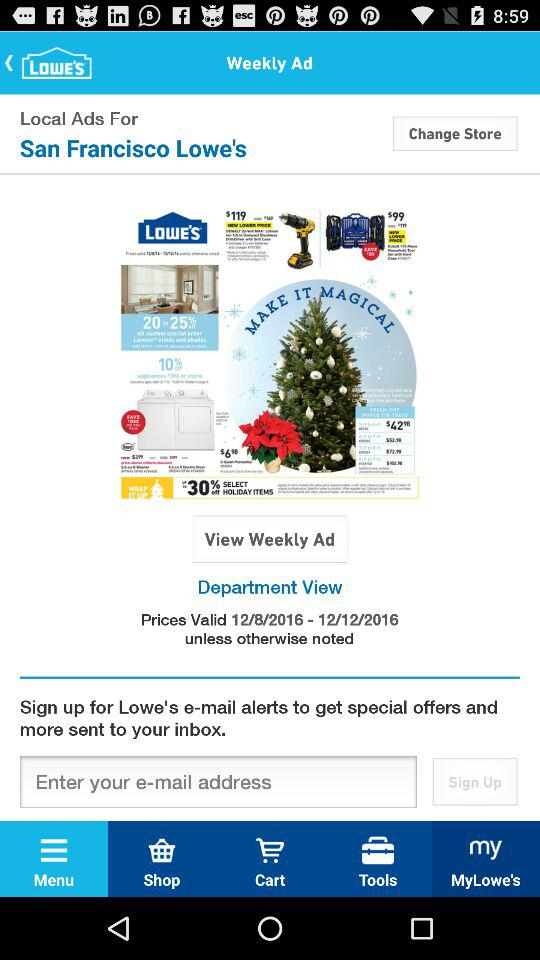What is the store name? The store name is "San Francisco Lowe's". 